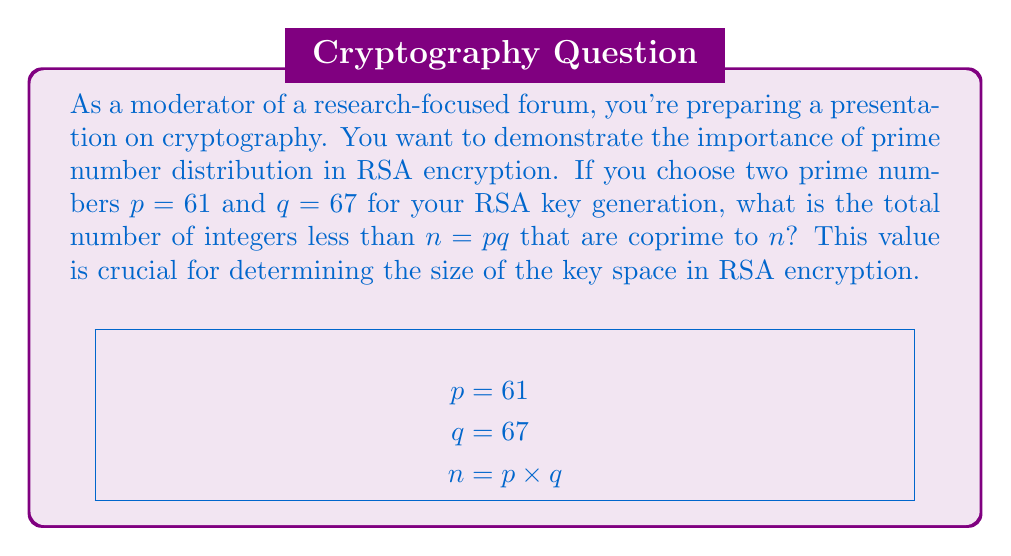Can you answer this question? To solve this problem, we'll follow these steps:

1) First, recall that in RSA encryption, $n = pq$ is the product of two prime numbers. In this case:
   
   $$n = 61 \times 67 = 4087$$

2) The number of integers less than $n$ and coprime to $n$ is given by Euler's totient function $\phi(n)$. For a product of two distinct primes, this function is calculated as:

   $$\phi(n) = \phi(p) \times \phi(q) = (p-1)(q-1)$$

3) This is because for a prime number $p$, all positive integers less than $p$ are coprime to it, so $\phi(p) = p-1$.

4) Let's calculate:
   
   $$\phi(4087) = (61-1)(67-1) = 60 \times 66$$

5) Multiply:
   
   $$\phi(4087) = 3960$$

This value, 3960, represents the size of the multiplicative group modulo $n$, which is crucial in RSA encryption. It determines the number of possible values for the public and private exponents, directly affecting the security of the encryption.
Answer: 3960 